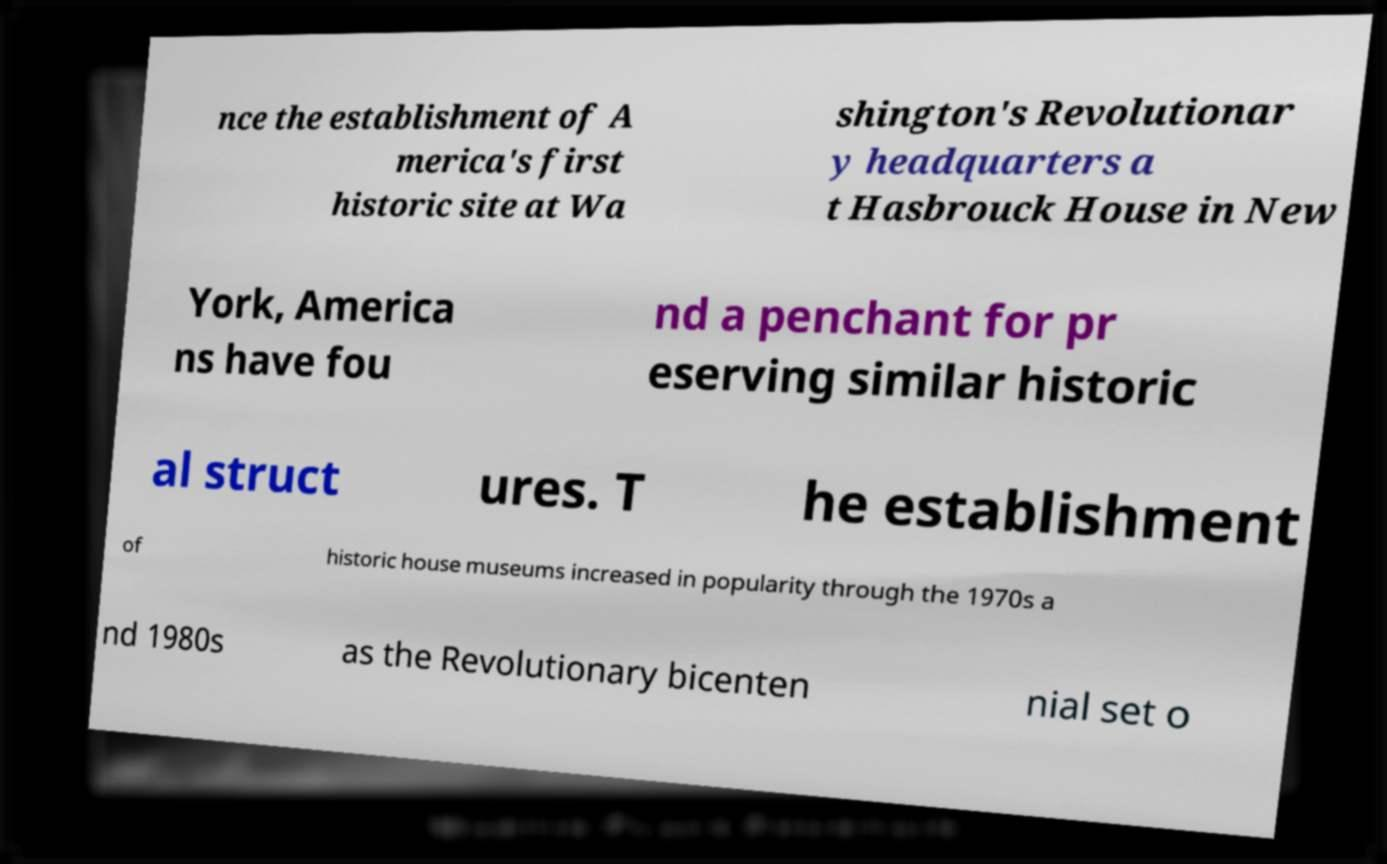What messages or text are displayed in this image? I need them in a readable, typed format. nce the establishment of A merica's first historic site at Wa shington's Revolutionar y headquarters a t Hasbrouck House in New York, America ns have fou nd a penchant for pr eserving similar historic al struct ures. T he establishment of historic house museums increased in popularity through the 1970s a nd 1980s as the Revolutionary bicenten nial set o 